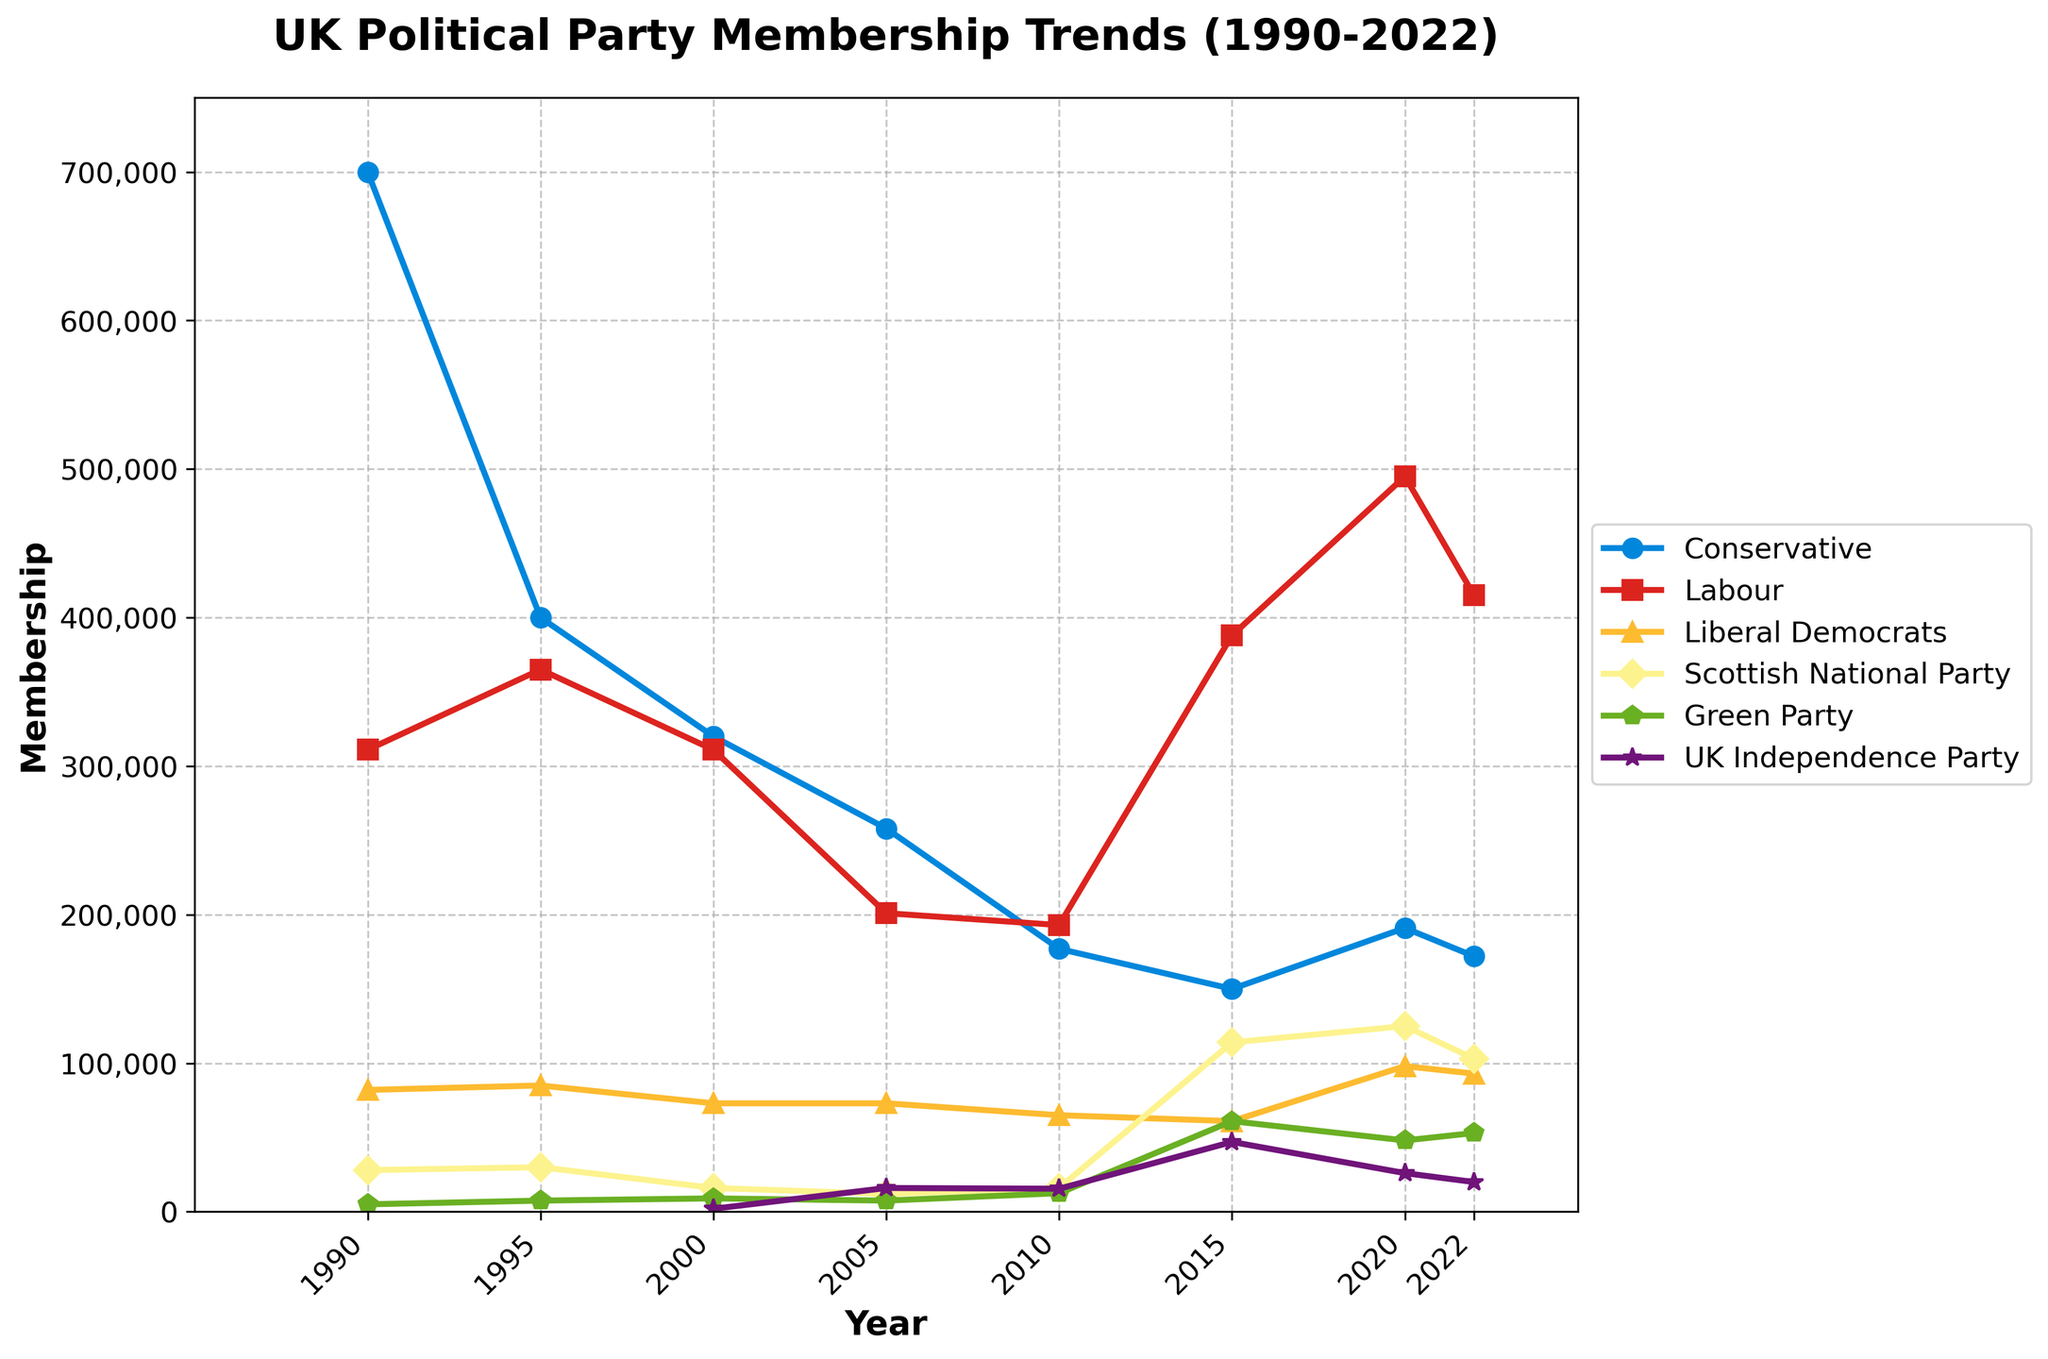What's the highest membership of the Labour Party? The highest membership can be found by scanning the Labour Party line for the peak value across the years shown on the plot. The Labour Party peaks at 495,000 in 2020.
Answer: 495,000 Between 1990 and 2022, which party experienced the largest increase in membership? To determine the largest increase, compare the difference in membership values from 1990 to 2022 for each party. The Scottish National Party increases from 28,000 in 1990 to 103,000 in 2022, an increase of 75,000. Other parties like the Conservatives and Labour see either a decline or smaller increases.
Answer: Scottish National Party What's the sum of Conservative and Labour Party memberships in 2000? Add the membership values of the two parties in the year 2000 from the plot: Conservative (320,000) and Labour (311,000). So, 320,000 + 311,000 = 631,000.
Answer: 631,000 How does the Green Party's membership in 2015 compare to the UK Independence Party's membership in the same year? Check the membership values for both parties in 2015. The Green Party has 61,000 members, whereas the UK Independence Party has 47,000 members. Therefore, the Green Party has a higher membership.
Answer: Green Party has more members Which year did the Liberal Democrats have their lowest membership? Scan the membership values for the Liberal Democrats across the years to find the lowest point. The lowest membership for the Liberal Democrats is in 2015 with 61,000 members.
Answer: 2015 What is the average membership of the Scottish National Party between 2010 and 2022? Calculate the average by adding the membership numbers for the SNP in 2010 (16,000), 2015 (114,000), 2020 (125,000), and 2022 (103,000). Then divide by the number of data points, which is 4. So, (16,000 + 114,000 + 125,000 + 103,000) / 4 = 89,500.
Answer: 89,500 In which year did the Conservative Party experience the sharpest decline in membership? Identify the years with the most significant decreases by comparing year-to-year values. The decline from 1990 (700,000) to 1995 (400,000) is the sharpest at 300,000 members.
Answer: 1990-1995 Which party had the smallest membership in 2005? Look at the membership numbers for all parties in 2005. SNP had 12,000 members, Green Party had 7,500 members, UK Independence Party had 16,000 members, and thus the Green Party had the smallest membership.
Answer: Green Party What color is the line representing the Liberal Democrats' membership trends? Observe the plot to identify the color of the line associated with the Liberal Democrats. The line for the Liberal Democrats is yellow.
Answer: Yellow 